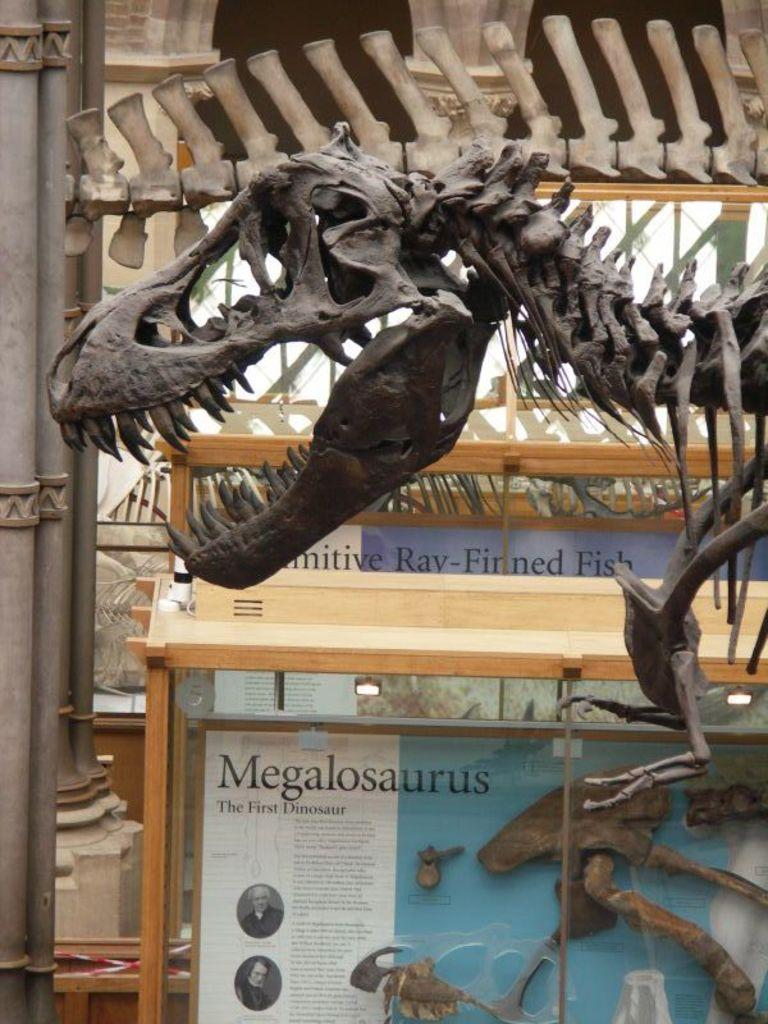What type of object can be seen in the image that is related to an animal's structure? There is a skeleton of an animal in the image. What other objects can be seen in the image? There are poles and boards in the image. What is attached to the boards? There are posters on the boards. What type of game is being played on the stove in the image? There is no stove or game present in the image. 